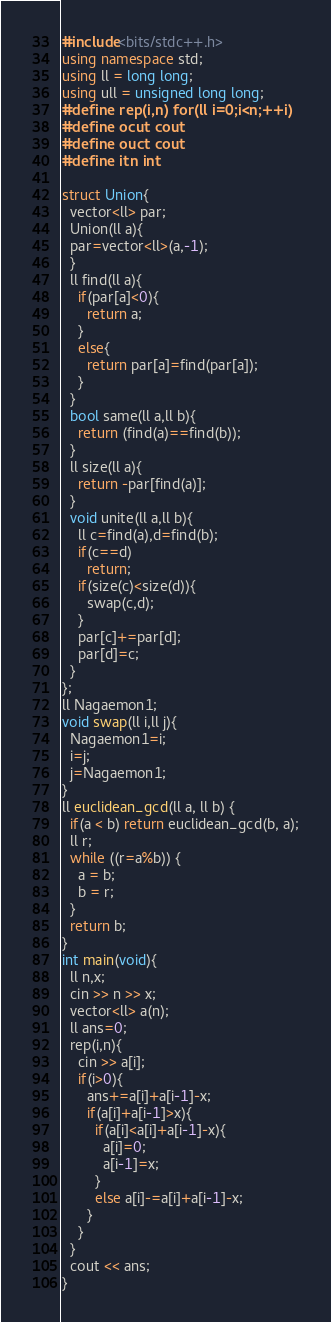Convert code to text. <code><loc_0><loc_0><loc_500><loc_500><_C++_>#include<bits/stdc++.h>
using namespace std;
using ll = long long;
using ull = unsigned long long;
#define rep(i,n) for(ll i=0;i<n;++i)
#define ocut cout
#define ouct cout
#define itn int

struct Union{
  vector<ll> par;
  Union(ll a){
  par=vector<ll>(a,-1);
  }
  ll find(ll a){
    if(par[a]<0){
      return a;
    }
    else{
      return par[a]=find(par[a]);
    }
  }
  bool same(ll a,ll b){
    return (find(a)==find(b));
  }
  ll size(ll a){
    return -par[find(a)];
  }
  void unite(ll a,ll b){
    ll c=find(a),d=find(b);
    if(c==d)
      return;
    if(size(c)<size(d)){
      swap(c,d);
    }
    par[c]+=par[d];
    par[d]=c;
  }
};
ll Nagaemon1;
void swap(ll i,ll j){
  Nagaemon1=i;
  i=j;
  j=Nagaemon1;
}
ll euclidean_gcd(ll a, ll b) {
  if(a < b) return euclidean_gcd(b, a);
  ll r;
  while ((r=a%b)) {
    a = b;
    b = r;
  }
  return b;
}
int main(void){
  ll n,x;
  cin >> n >> x;
  vector<ll> a(n);
  ll ans=0;
  rep(i,n){
    cin >> a[i];
    if(i>0){
      ans+=a[i]+a[i-1]-x;
      if(a[i]+a[i-1]>x){
        if(a[i]<a[i]+a[i-1]-x){
          a[i]=0;
          a[i-1]=x;
        }
        else a[i]-=a[i]+a[i-1]-x;
      }
    }
  }
  cout << ans;
}</code> 